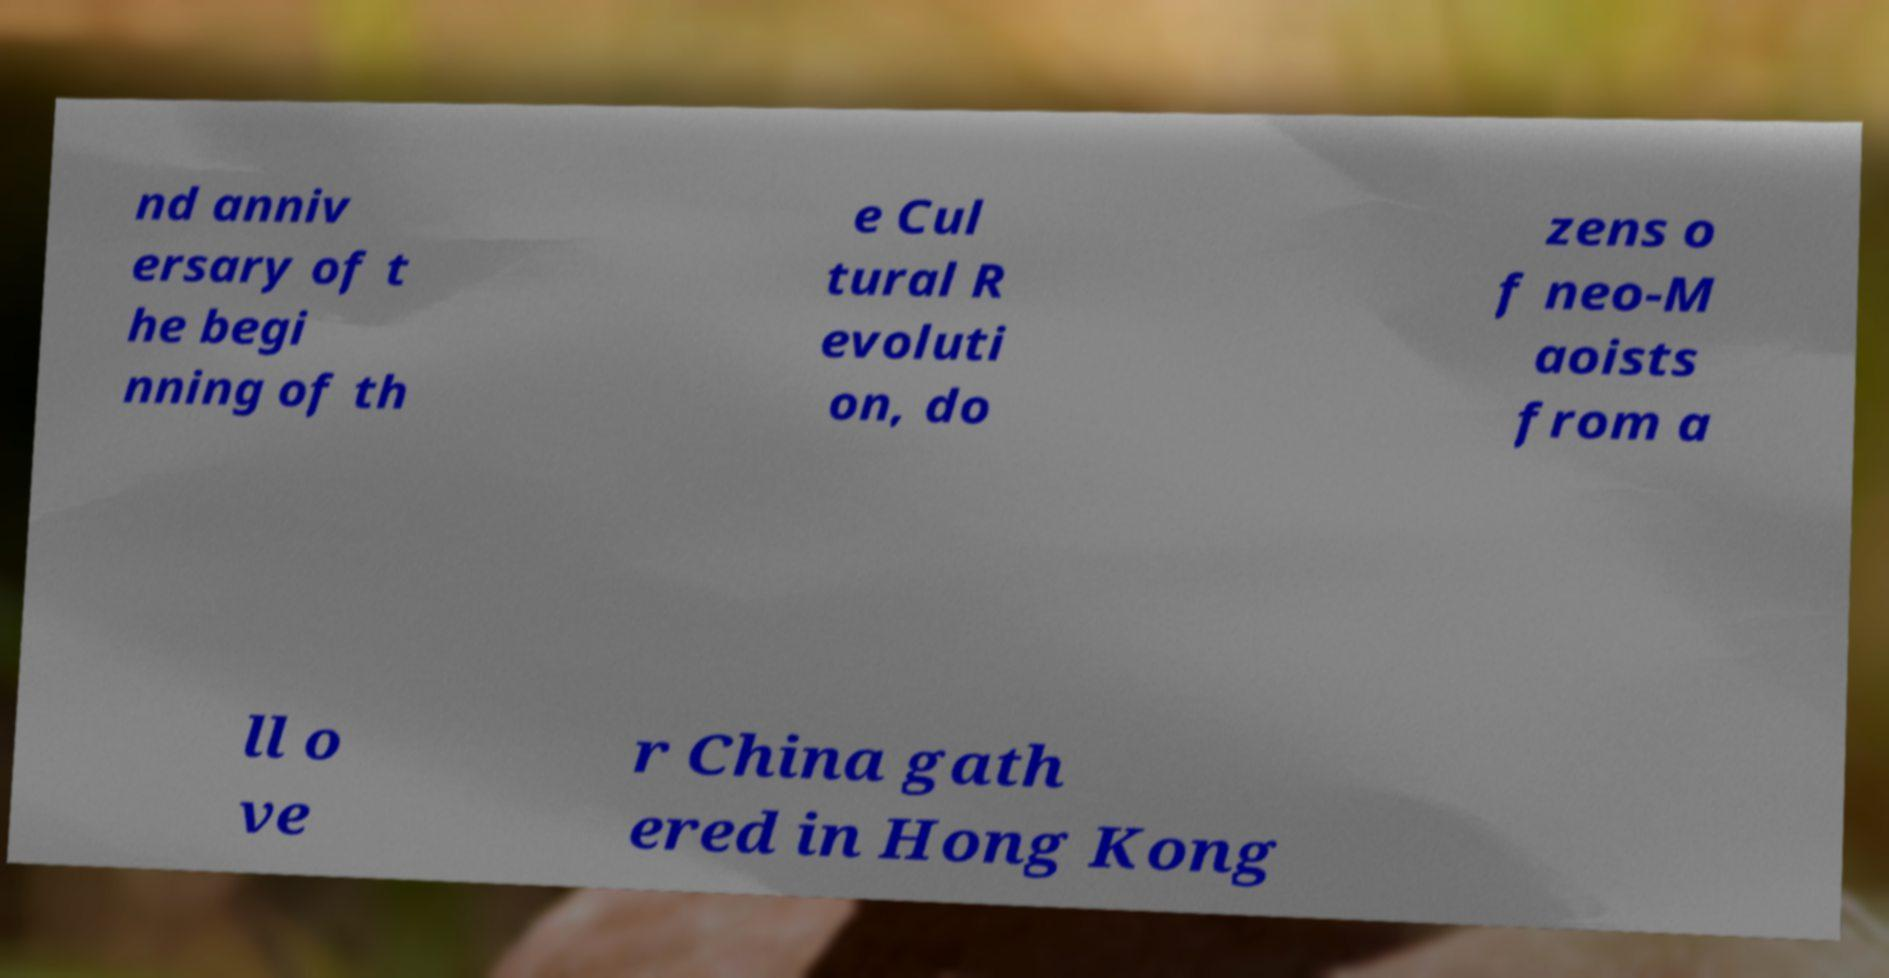Please identify and transcribe the text found in this image. nd anniv ersary of t he begi nning of th e Cul tural R evoluti on, do zens o f neo-M aoists from a ll o ve r China gath ered in Hong Kong 